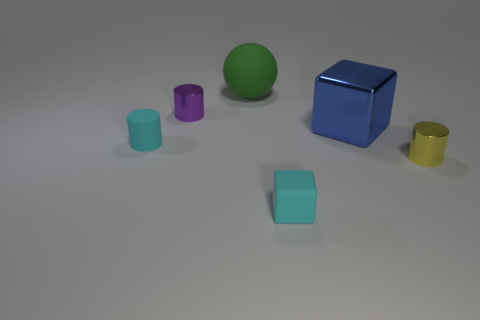There is a small cyan thing that is to the left of the tiny cyan rubber thing to the right of the cyan cylinder that is left of the rubber block; what is it made of?
Your response must be concise. Rubber. The other rubber object that is the same size as the blue object is what shape?
Ensure brevity in your answer.  Sphere. Is there a tiny rubber thing that has the same color as the small block?
Ensure brevity in your answer.  Yes. The ball has what size?
Keep it short and to the point. Large. Do the cyan cylinder and the tiny yellow cylinder have the same material?
Your answer should be compact. No. There is a small cyan matte thing behind the cyan object on the right side of the tiny purple cylinder; how many cylinders are to the right of it?
Make the answer very short. 2. There is a metallic object behind the large blue metal object; what is its shape?
Your answer should be very brief. Cylinder. Is the color of the tiny rubber block the same as the large rubber sphere?
Provide a succinct answer. No. Is the number of large green balls that are to the right of the large blue block less than the number of metal objects that are left of the large green matte ball?
Offer a very short reply. Yes. The small rubber object that is the same shape as the blue metal thing is what color?
Your answer should be very brief. Cyan. 